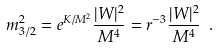<formula> <loc_0><loc_0><loc_500><loc_500>m _ { 3 / 2 } ^ { 2 } = e ^ { K / M ^ { 2 } } \frac { | W | ^ { 2 } } { M ^ { 4 } } = r ^ { - 3 } \frac { | W | ^ { 2 } } { M ^ { 4 } } \ .</formula> 